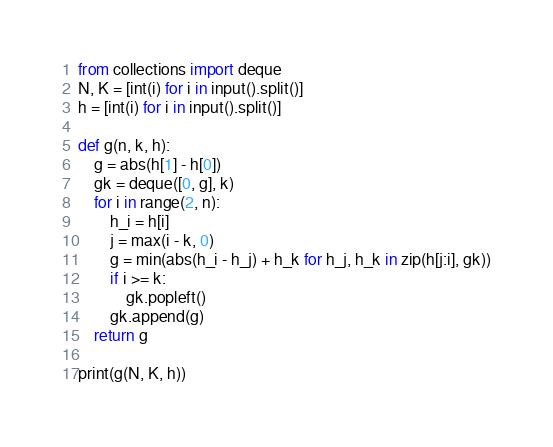<code> <loc_0><loc_0><loc_500><loc_500><_Python_>from collections import deque
N, K = [int(i) for i in input().split()]
h = [int(i) for i in input().split()]

def g(n, k, h):
    g = abs(h[1] - h[0])
    gk = deque([0, g], k)
    for i in range(2, n):
        h_i = h[i]
        j = max(i - k, 0)
        g = min(abs(h_i - h_j) + h_k for h_j, h_k in zip(h[j:i], gk))
        if i >= k:
            gk.popleft()
        gk.append(g)
    return g

print(g(N, K, h))
</code> 